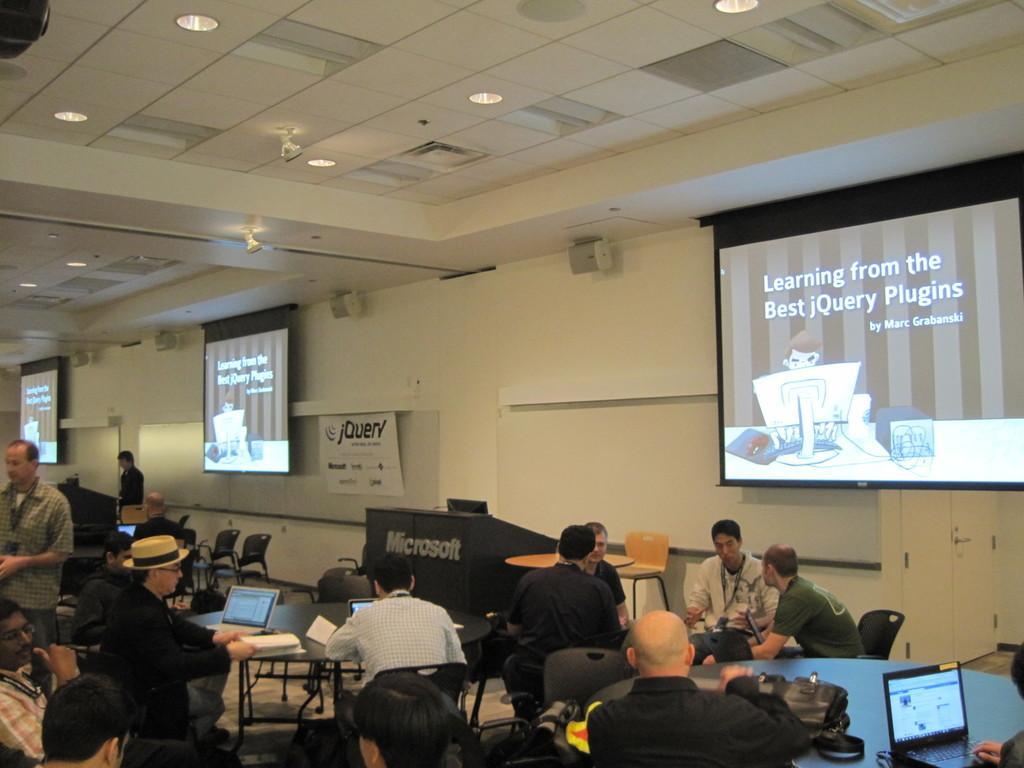Could you give a brief overview of what you see in this image? In this picture we can see a group of people where some are sitting on chairs and some are standing and in front of them on tables we can see a bag, laptops and in the background we can see wall, screens. 